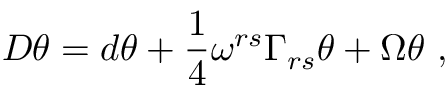<formula> <loc_0><loc_0><loc_500><loc_500>D \theta = d \theta + \frac { 1 } { 4 } \omega ^ { r s } \Gamma _ { r s } \theta + \Omega \theta ,</formula> 